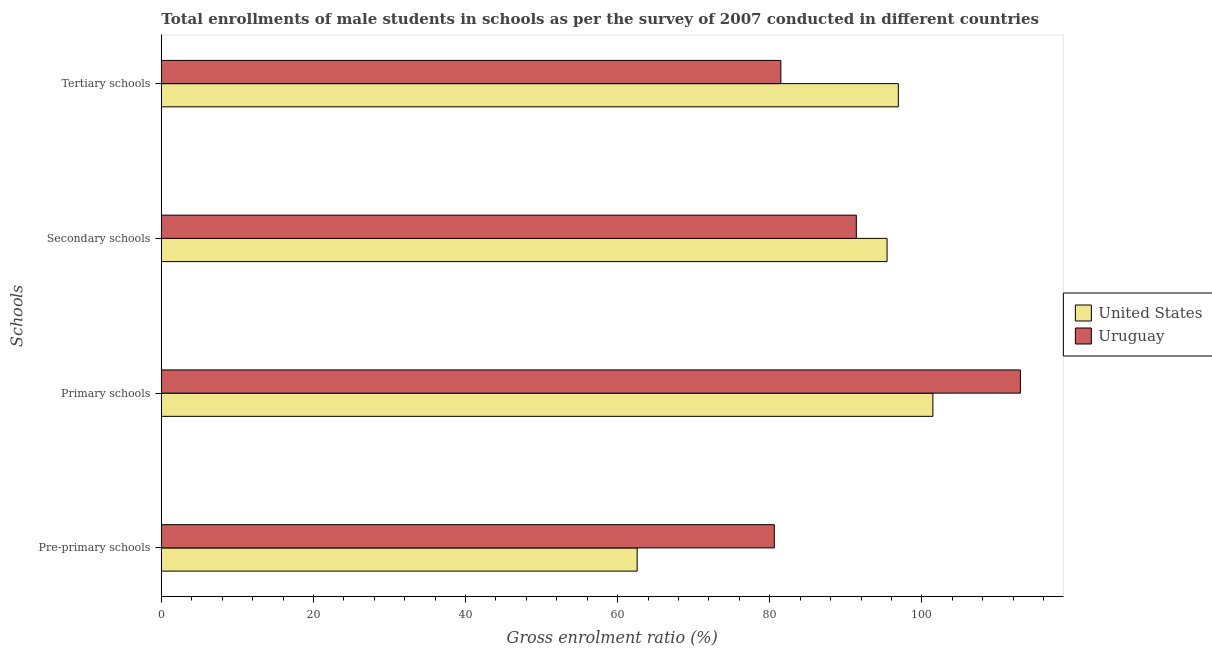How many different coloured bars are there?
Make the answer very short. 2. How many groups of bars are there?
Your response must be concise. 4. Are the number of bars per tick equal to the number of legend labels?
Your answer should be very brief. Yes. How many bars are there on the 3rd tick from the top?
Keep it short and to the point. 2. How many bars are there on the 2nd tick from the bottom?
Provide a short and direct response. 2. What is the label of the 4th group of bars from the top?
Offer a very short reply. Pre-primary schools. What is the gross enrolment ratio(male) in primary schools in Uruguay?
Provide a short and direct response. 112.95. Across all countries, what is the maximum gross enrolment ratio(male) in pre-primary schools?
Offer a very short reply. 80.6. Across all countries, what is the minimum gross enrolment ratio(male) in primary schools?
Offer a very short reply. 101.45. In which country was the gross enrolment ratio(male) in primary schools maximum?
Provide a succinct answer. Uruguay. In which country was the gross enrolment ratio(male) in pre-primary schools minimum?
Your answer should be very brief. United States. What is the total gross enrolment ratio(male) in tertiary schools in the graph?
Provide a short and direct response. 178.36. What is the difference between the gross enrolment ratio(male) in secondary schools in Uruguay and that in United States?
Provide a succinct answer. -4.04. What is the difference between the gross enrolment ratio(male) in secondary schools in Uruguay and the gross enrolment ratio(male) in primary schools in United States?
Offer a very short reply. -10.06. What is the average gross enrolment ratio(male) in secondary schools per country?
Make the answer very short. 93.4. What is the difference between the gross enrolment ratio(male) in secondary schools and gross enrolment ratio(male) in primary schools in Uruguay?
Give a very brief answer. -21.57. In how many countries, is the gross enrolment ratio(male) in secondary schools greater than 56 %?
Your answer should be compact. 2. What is the ratio of the gross enrolment ratio(male) in pre-primary schools in United States to that in Uruguay?
Give a very brief answer. 0.78. What is the difference between the highest and the second highest gross enrolment ratio(male) in tertiary schools?
Make the answer very short. 15.45. What is the difference between the highest and the lowest gross enrolment ratio(male) in secondary schools?
Your answer should be compact. 4.04. What does the 1st bar from the top in Secondary schools represents?
Keep it short and to the point. Uruguay. What is the difference between two consecutive major ticks on the X-axis?
Make the answer very short. 20. Does the graph contain any zero values?
Keep it short and to the point. No. Does the graph contain grids?
Your answer should be very brief. No. Where does the legend appear in the graph?
Offer a terse response. Center right. What is the title of the graph?
Offer a terse response. Total enrollments of male students in schools as per the survey of 2007 conducted in different countries. What is the label or title of the X-axis?
Give a very brief answer. Gross enrolment ratio (%). What is the label or title of the Y-axis?
Offer a terse response. Schools. What is the Gross enrolment ratio (%) in United States in Pre-primary schools?
Offer a very short reply. 62.57. What is the Gross enrolment ratio (%) of Uruguay in Pre-primary schools?
Your answer should be compact. 80.6. What is the Gross enrolment ratio (%) of United States in Primary schools?
Ensure brevity in your answer.  101.45. What is the Gross enrolment ratio (%) of Uruguay in Primary schools?
Your answer should be compact. 112.95. What is the Gross enrolment ratio (%) in United States in Secondary schools?
Your answer should be compact. 95.42. What is the Gross enrolment ratio (%) of Uruguay in Secondary schools?
Your answer should be very brief. 91.38. What is the Gross enrolment ratio (%) in United States in Tertiary schools?
Your response must be concise. 96.9. What is the Gross enrolment ratio (%) in Uruguay in Tertiary schools?
Provide a succinct answer. 81.46. Across all Schools, what is the maximum Gross enrolment ratio (%) of United States?
Your answer should be very brief. 101.45. Across all Schools, what is the maximum Gross enrolment ratio (%) in Uruguay?
Provide a succinct answer. 112.95. Across all Schools, what is the minimum Gross enrolment ratio (%) in United States?
Your response must be concise. 62.57. Across all Schools, what is the minimum Gross enrolment ratio (%) of Uruguay?
Offer a terse response. 80.6. What is the total Gross enrolment ratio (%) in United States in the graph?
Keep it short and to the point. 356.34. What is the total Gross enrolment ratio (%) in Uruguay in the graph?
Ensure brevity in your answer.  366.39. What is the difference between the Gross enrolment ratio (%) of United States in Pre-primary schools and that in Primary schools?
Make the answer very short. -38.88. What is the difference between the Gross enrolment ratio (%) of Uruguay in Pre-primary schools and that in Primary schools?
Your answer should be compact. -32.36. What is the difference between the Gross enrolment ratio (%) of United States in Pre-primary schools and that in Secondary schools?
Offer a terse response. -32.86. What is the difference between the Gross enrolment ratio (%) of Uruguay in Pre-primary schools and that in Secondary schools?
Offer a terse response. -10.78. What is the difference between the Gross enrolment ratio (%) in United States in Pre-primary schools and that in Tertiary schools?
Provide a succinct answer. -34.34. What is the difference between the Gross enrolment ratio (%) in Uruguay in Pre-primary schools and that in Tertiary schools?
Provide a succinct answer. -0.86. What is the difference between the Gross enrolment ratio (%) of United States in Primary schools and that in Secondary schools?
Give a very brief answer. 6.02. What is the difference between the Gross enrolment ratio (%) of Uruguay in Primary schools and that in Secondary schools?
Provide a short and direct response. 21.57. What is the difference between the Gross enrolment ratio (%) in United States in Primary schools and that in Tertiary schools?
Give a very brief answer. 4.54. What is the difference between the Gross enrolment ratio (%) in Uruguay in Primary schools and that in Tertiary schools?
Give a very brief answer. 31.5. What is the difference between the Gross enrolment ratio (%) of United States in Secondary schools and that in Tertiary schools?
Provide a short and direct response. -1.48. What is the difference between the Gross enrolment ratio (%) of Uruguay in Secondary schools and that in Tertiary schools?
Offer a terse response. 9.92. What is the difference between the Gross enrolment ratio (%) of United States in Pre-primary schools and the Gross enrolment ratio (%) of Uruguay in Primary schools?
Keep it short and to the point. -50.39. What is the difference between the Gross enrolment ratio (%) in United States in Pre-primary schools and the Gross enrolment ratio (%) in Uruguay in Secondary schools?
Your answer should be compact. -28.81. What is the difference between the Gross enrolment ratio (%) in United States in Pre-primary schools and the Gross enrolment ratio (%) in Uruguay in Tertiary schools?
Keep it short and to the point. -18.89. What is the difference between the Gross enrolment ratio (%) of United States in Primary schools and the Gross enrolment ratio (%) of Uruguay in Secondary schools?
Your answer should be compact. 10.06. What is the difference between the Gross enrolment ratio (%) of United States in Primary schools and the Gross enrolment ratio (%) of Uruguay in Tertiary schools?
Provide a short and direct response. 19.99. What is the difference between the Gross enrolment ratio (%) of United States in Secondary schools and the Gross enrolment ratio (%) of Uruguay in Tertiary schools?
Give a very brief answer. 13.97. What is the average Gross enrolment ratio (%) of United States per Schools?
Provide a short and direct response. 89.08. What is the average Gross enrolment ratio (%) of Uruguay per Schools?
Your answer should be compact. 91.6. What is the difference between the Gross enrolment ratio (%) in United States and Gross enrolment ratio (%) in Uruguay in Pre-primary schools?
Ensure brevity in your answer.  -18.03. What is the difference between the Gross enrolment ratio (%) of United States and Gross enrolment ratio (%) of Uruguay in Primary schools?
Provide a succinct answer. -11.51. What is the difference between the Gross enrolment ratio (%) of United States and Gross enrolment ratio (%) of Uruguay in Secondary schools?
Provide a succinct answer. 4.04. What is the difference between the Gross enrolment ratio (%) of United States and Gross enrolment ratio (%) of Uruguay in Tertiary schools?
Your answer should be very brief. 15.45. What is the ratio of the Gross enrolment ratio (%) in United States in Pre-primary schools to that in Primary schools?
Make the answer very short. 0.62. What is the ratio of the Gross enrolment ratio (%) in Uruguay in Pre-primary schools to that in Primary schools?
Give a very brief answer. 0.71. What is the ratio of the Gross enrolment ratio (%) of United States in Pre-primary schools to that in Secondary schools?
Your answer should be very brief. 0.66. What is the ratio of the Gross enrolment ratio (%) of Uruguay in Pre-primary schools to that in Secondary schools?
Offer a very short reply. 0.88. What is the ratio of the Gross enrolment ratio (%) of United States in Pre-primary schools to that in Tertiary schools?
Offer a very short reply. 0.65. What is the ratio of the Gross enrolment ratio (%) of United States in Primary schools to that in Secondary schools?
Your answer should be compact. 1.06. What is the ratio of the Gross enrolment ratio (%) in Uruguay in Primary schools to that in Secondary schools?
Your response must be concise. 1.24. What is the ratio of the Gross enrolment ratio (%) of United States in Primary schools to that in Tertiary schools?
Offer a terse response. 1.05. What is the ratio of the Gross enrolment ratio (%) in Uruguay in Primary schools to that in Tertiary schools?
Your answer should be compact. 1.39. What is the ratio of the Gross enrolment ratio (%) of United States in Secondary schools to that in Tertiary schools?
Your answer should be compact. 0.98. What is the ratio of the Gross enrolment ratio (%) in Uruguay in Secondary schools to that in Tertiary schools?
Make the answer very short. 1.12. What is the difference between the highest and the second highest Gross enrolment ratio (%) in United States?
Offer a very short reply. 4.54. What is the difference between the highest and the second highest Gross enrolment ratio (%) in Uruguay?
Ensure brevity in your answer.  21.57. What is the difference between the highest and the lowest Gross enrolment ratio (%) in United States?
Offer a terse response. 38.88. What is the difference between the highest and the lowest Gross enrolment ratio (%) in Uruguay?
Your answer should be very brief. 32.36. 